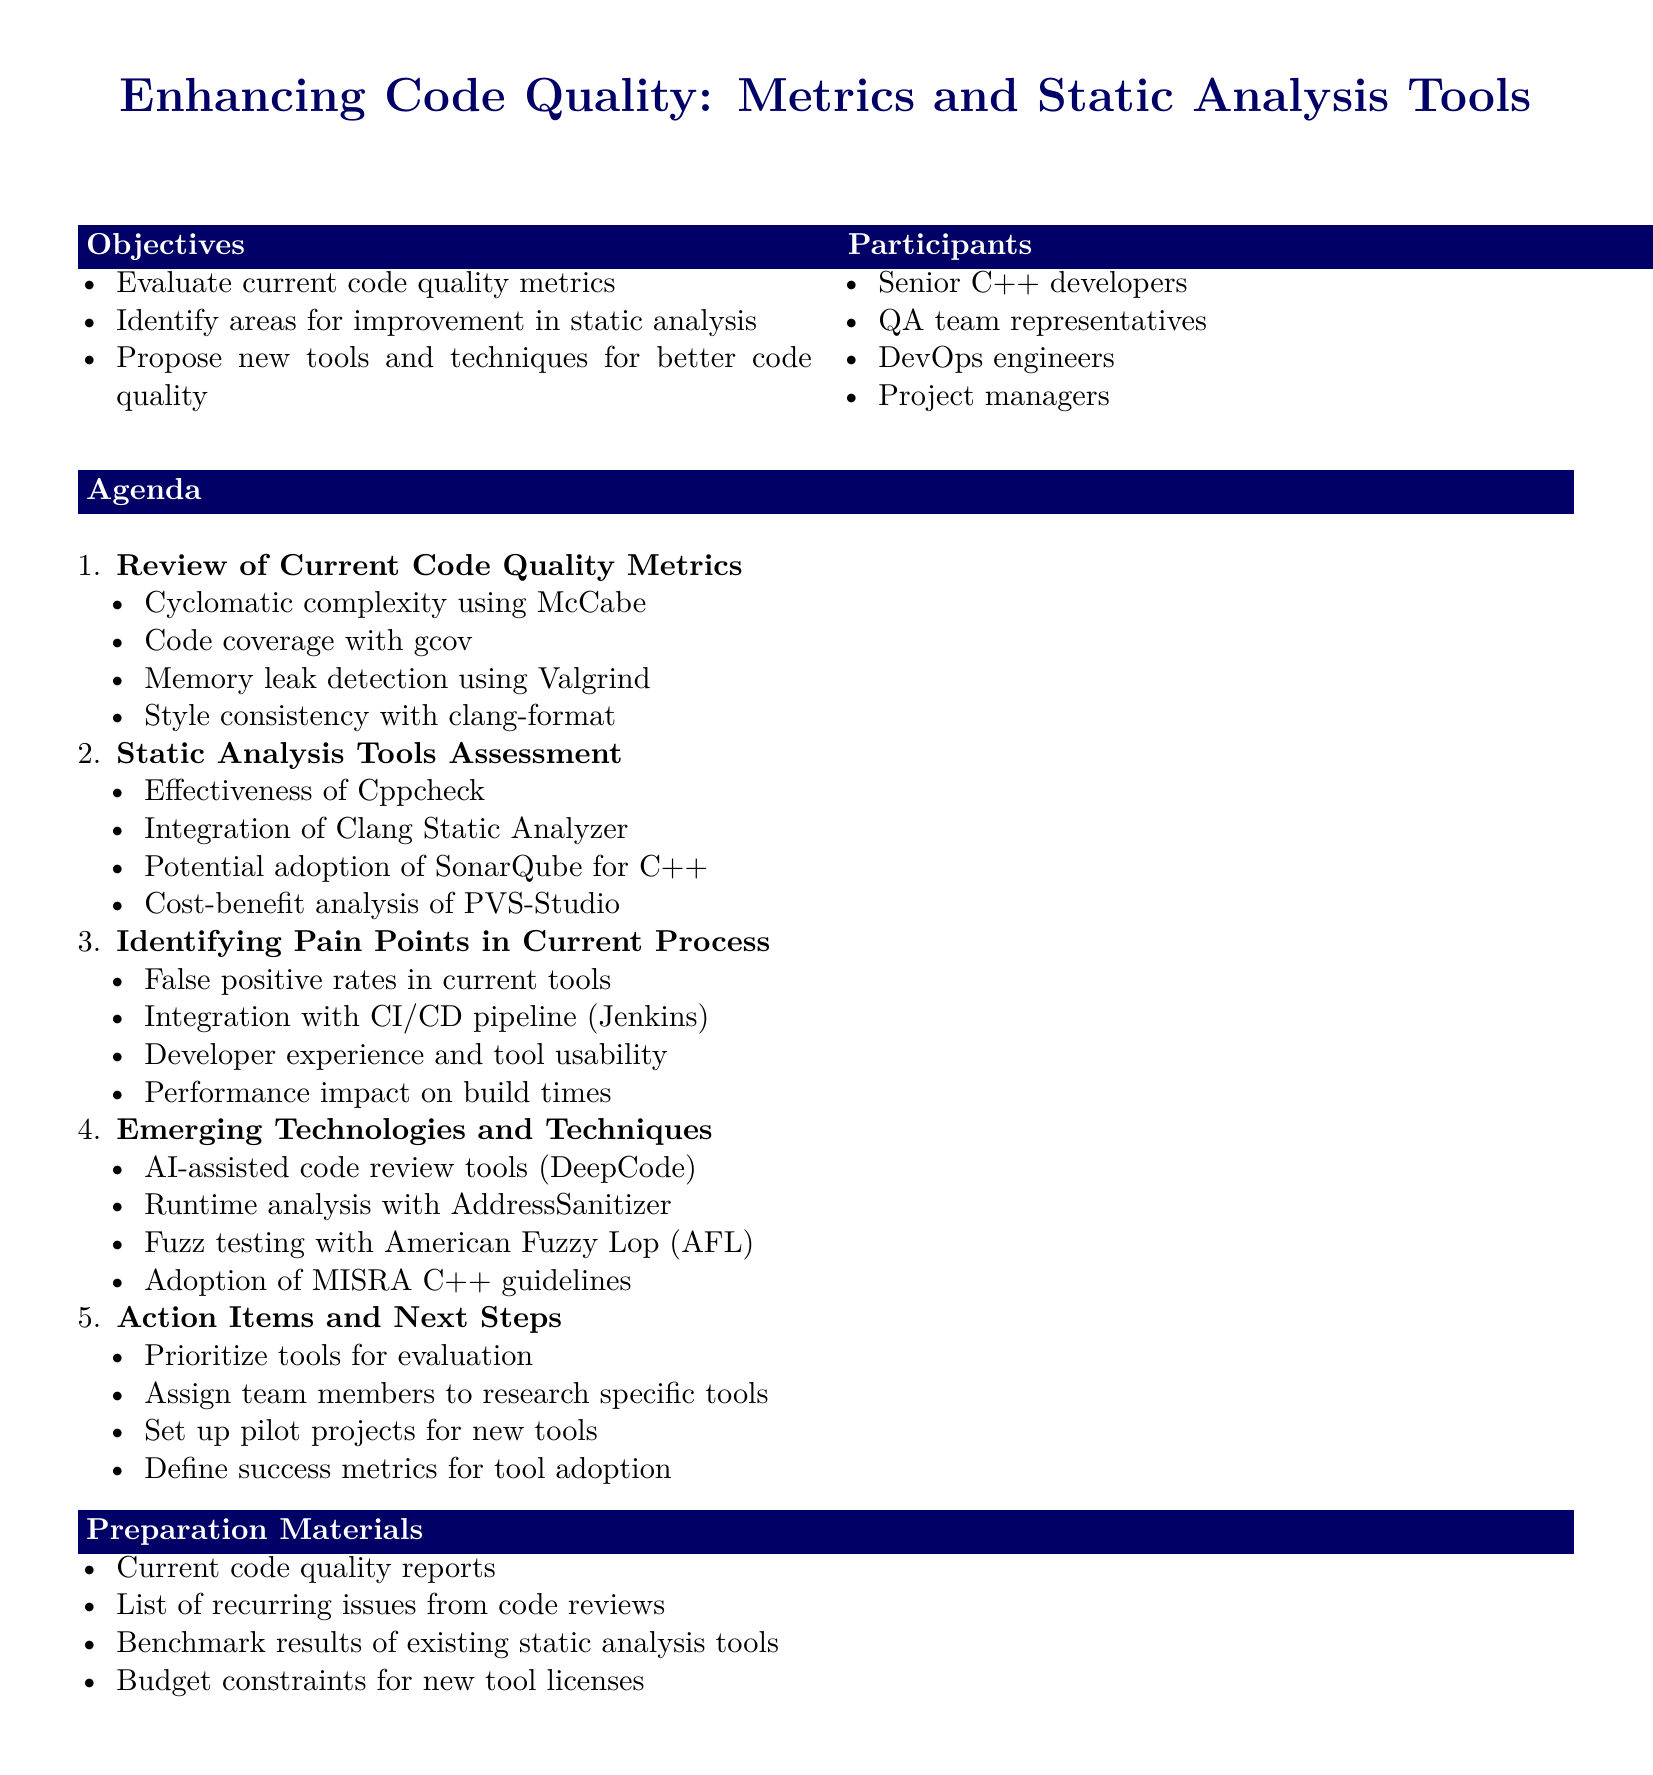What is the meeting title? The title of the meeting is presented at the beginning of the document.
Answer: Enhancing Code Quality: Metrics and Static Analysis Tools How many objectives are listed? The number of objectives is mentioned in the Objectives section of the document.
Answer: 3 What is one of the current code quality metrics being reviewed? A specific metric is listed in the Review of Current Code Quality Metrics section.
Answer: Cyclomatic complexity using McCabe Which tool is suggested for potential adoption in static analysis? The document mentions a specific tool in the Static Analysis Tools Assessment section.
Answer: SonarQube What pain point relates to tool effectiveness? This question refers to a specific subtopic under Identifying Pain Points in Current Process.
Answer: False positive rates in current tools What is one emerging technology mentioned? Emerging technologies are highlighted in the Emerging Technologies and Techniques section.
Answer: AI-assisted code review tools (DeepCode) What is one action item for the meeting? The Action Items and Next Steps section outlines specific tasks to be accomplished.
Answer: Prioritize tools for evaluation How many main agenda items are there? The number of agenda items is reflected in the enumerated list of the Agenda section.
Answer: 5 